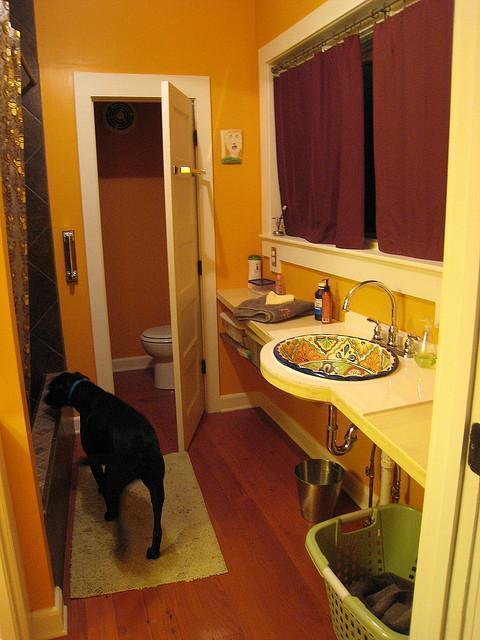What type of dog is this?
Choose the right answer from the provided options to respond to the question.
Options: Chow, black lab, poodle, chihuahua. Black lab. 